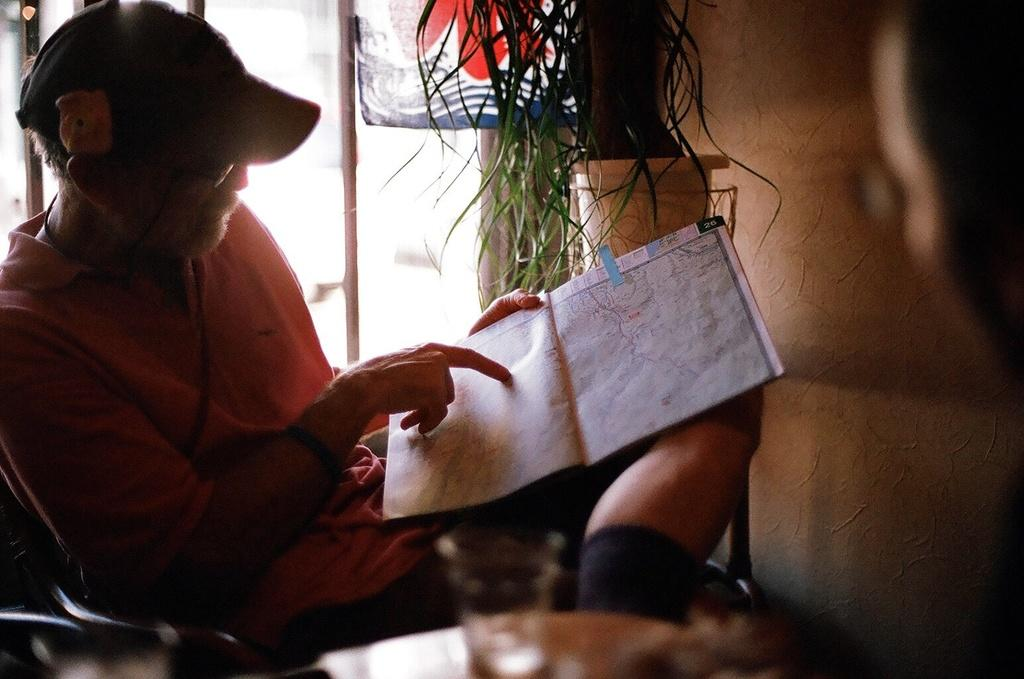What is the man in the image doing? The man is sitting in a chair in the image. What is the man holding in the image? The man is holding a map in the image. What can be seen in the background of the image? There is a wall and a plant in the background of the image. What is on the table at the bottom of the image? There is a glass on a table at the bottom of the image. What does the father say to the man before he leaves in the image? There is no father or indication of anyone leaving in the image. 